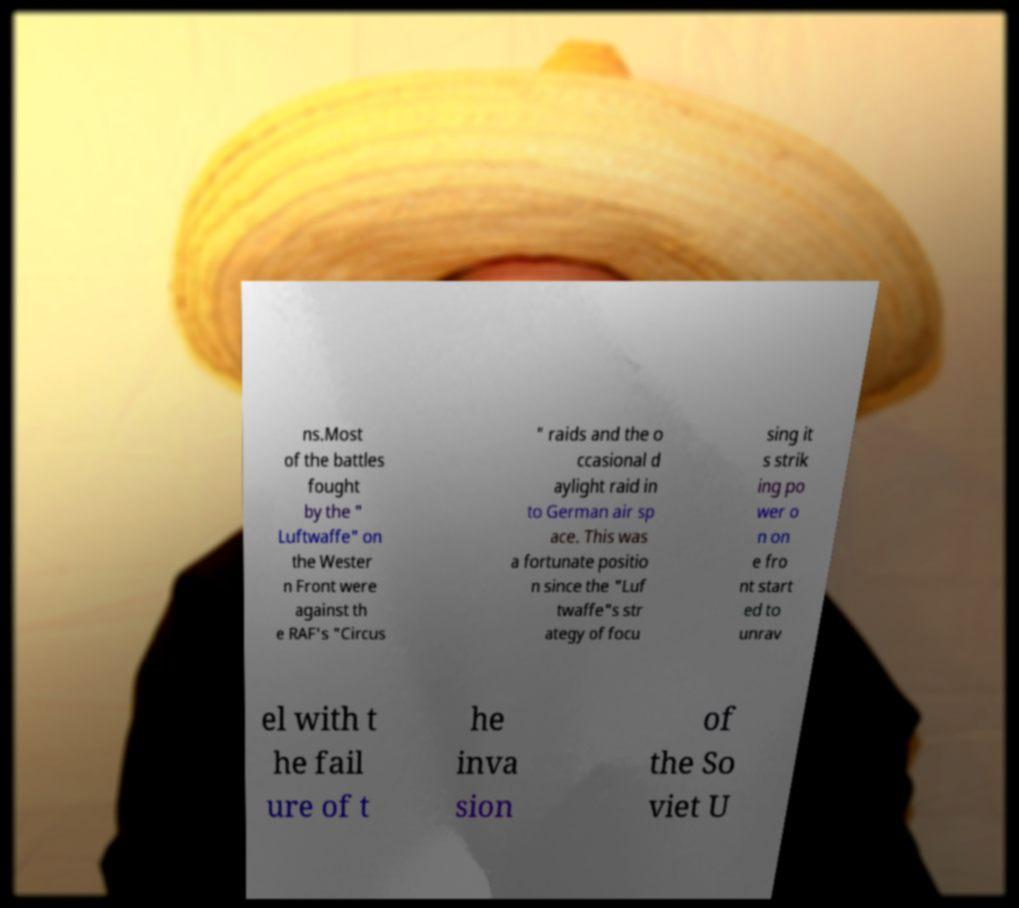Can you accurately transcribe the text from the provided image for me? ns.Most of the battles fought by the " Luftwaffe" on the Wester n Front were against th e RAF's "Circus " raids and the o ccasional d aylight raid in to German air sp ace. This was a fortunate positio n since the "Luf twaffe"s str ategy of focu sing it s strik ing po wer o n on e fro nt start ed to unrav el with t he fail ure of t he inva sion of the So viet U 